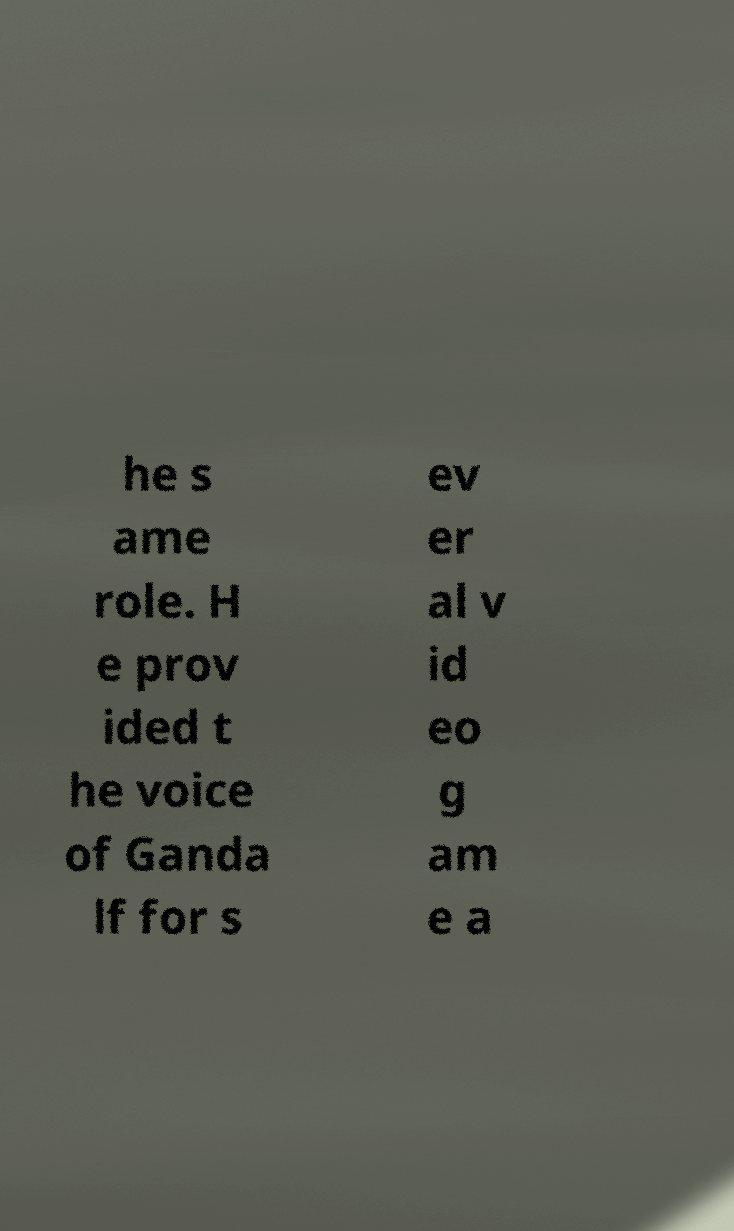Please identify and transcribe the text found in this image. he s ame role. H e prov ided t he voice of Ganda lf for s ev er al v id eo g am e a 